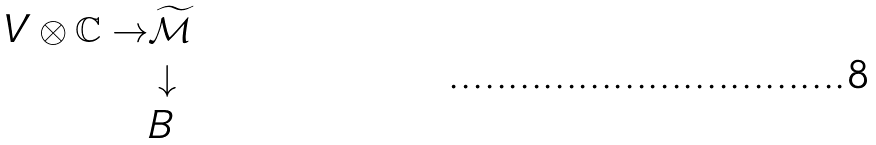<formula> <loc_0><loc_0><loc_500><loc_500>V \otimes \mathbb { C } \to & \widetilde { \mathcal { M } } \\ & \downarrow \\ & B</formula> 